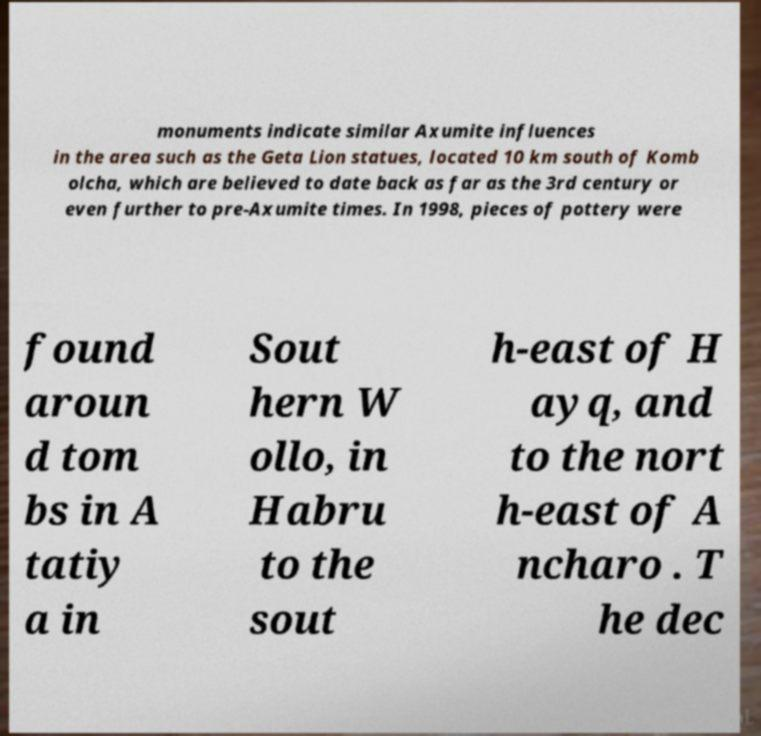There's text embedded in this image that I need extracted. Can you transcribe it verbatim? monuments indicate similar Axumite influences in the area such as the Geta Lion statues, located 10 km south of Komb olcha, which are believed to date back as far as the 3rd century or even further to pre-Axumite times. In 1998, pieces of pottery were found aroun d tom bs in A tatiy a in Sout hern W ollo, in Habru to the sout h-east of H ayq, and to the nort h-east of A ncharo . T he dec 